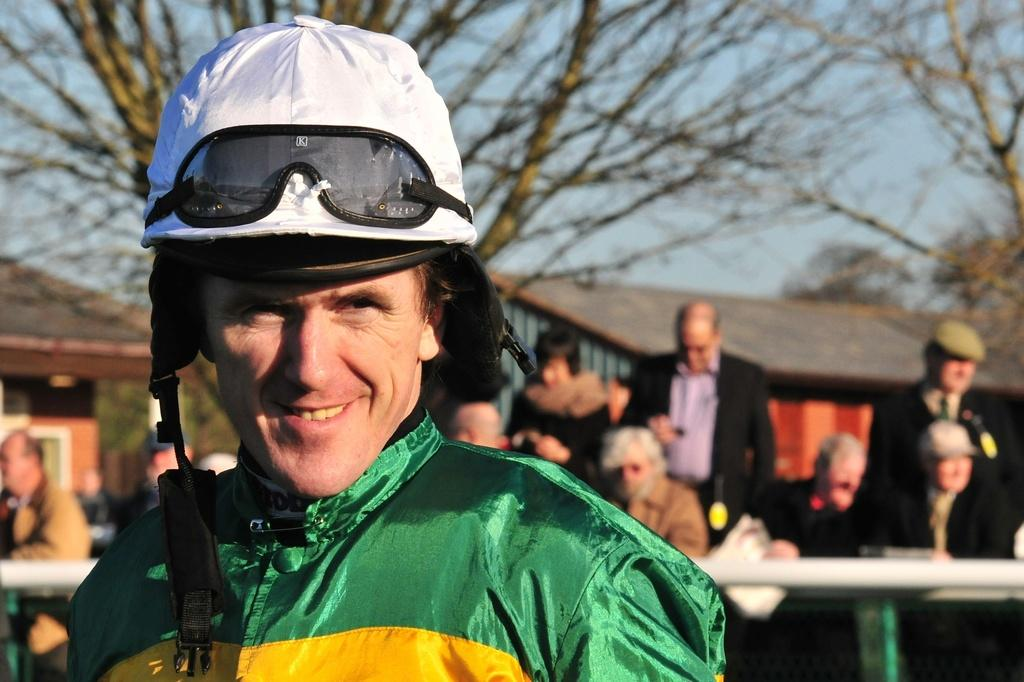What is the person in the image wearing on their head? The person in the image is wearing a cap. Can you describe the people behind the person wearing the cap? There are other people behind the person wearing the cap. What type of furniture is present in the image? Tables are present in the image. What type of structures can be seen in the background of the image? Houses are visible in the image. What type of natural elements are present in the image? Trees are present in the image. What type of chess pieces can be seen on the table in the image? There is no chess set present in the image; only tables, houses, trees, and people are visible. What type of battle is taking place in the image? There is no battle depicted in the image; it shows a person wearing a cap, other people, tables, houses, and trees. 